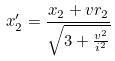<formula> <loc_0><loc_0><loc_500><loc_500>x _ { 2 } ^ { \prime } = \frac { x _ { 2 } + v r _ { 2 } } { \sqrt { 3 + \frac { v ^ { 2 } } { i ^ { 2 } } } }</formula> 